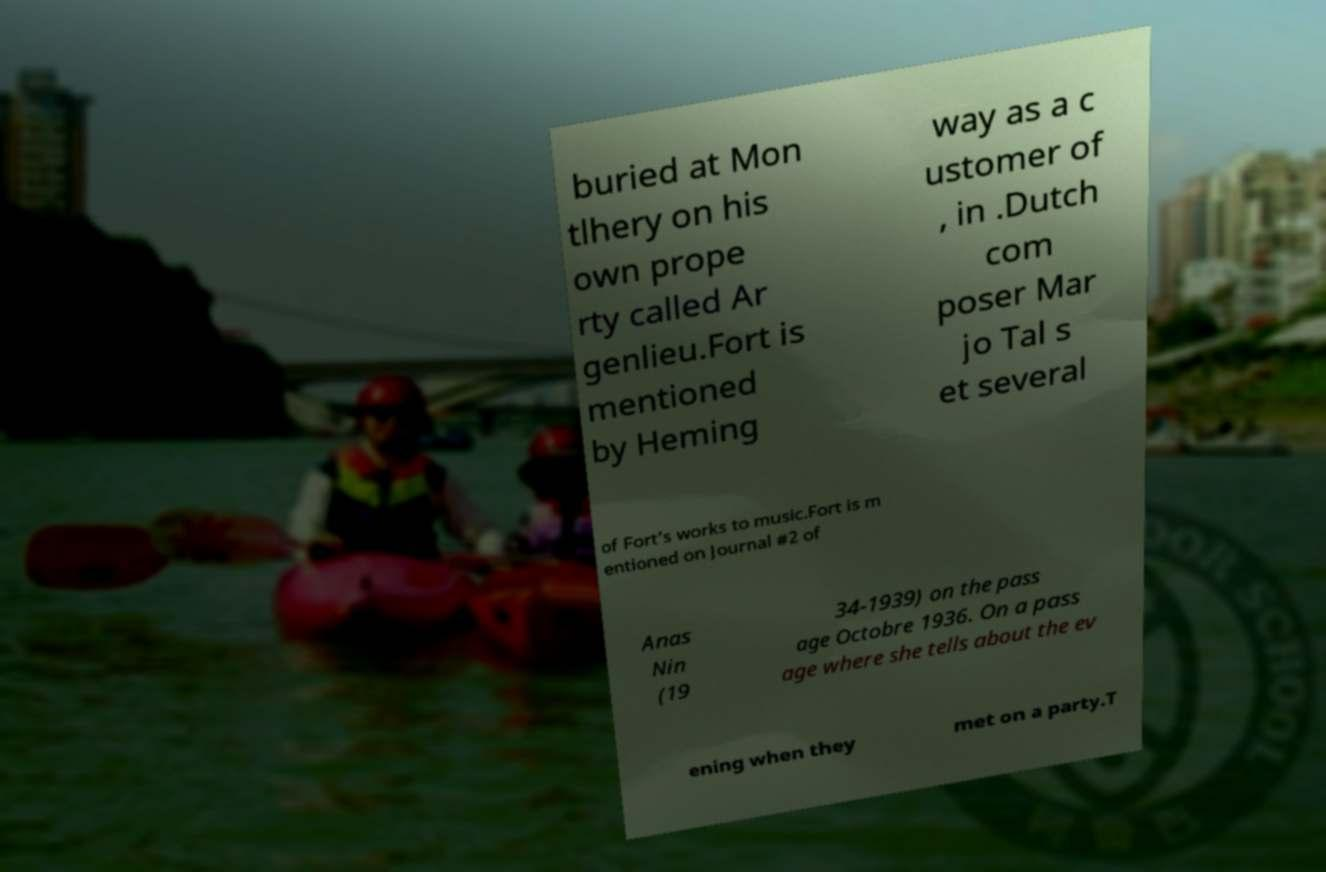Please identify and transcribe the text found in this image. buried at Mon tlhery on his own prope rty called Ar genlieu.Fort is mentioned by Heming way as a c ustomer of , in .Dutch com poser Mar jo Tal s et several of Fort’s works to music.Fort is m entioned on Journal #2 of Anas Nin (19 34-1939) on the pass age Octobre 1936. On a pass age where she tells about the ev ening when they met on a party.T 